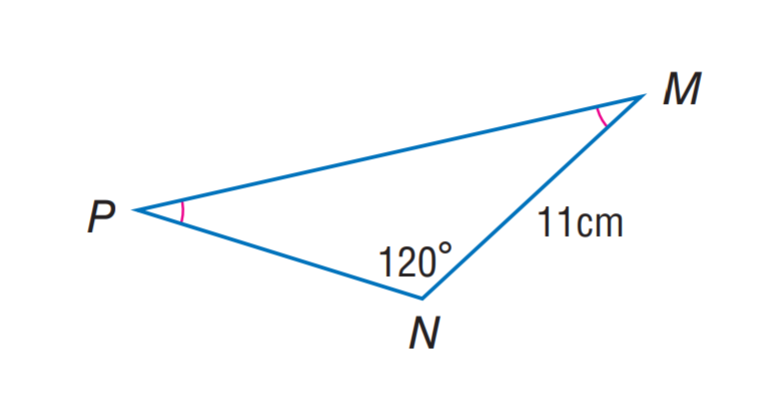Answer the mathemtical geometry problem and directly provide the correct option letter.
Question: Find m \angle M.
Choices: A: 20 B: 30 C: 60 D: 120 B 